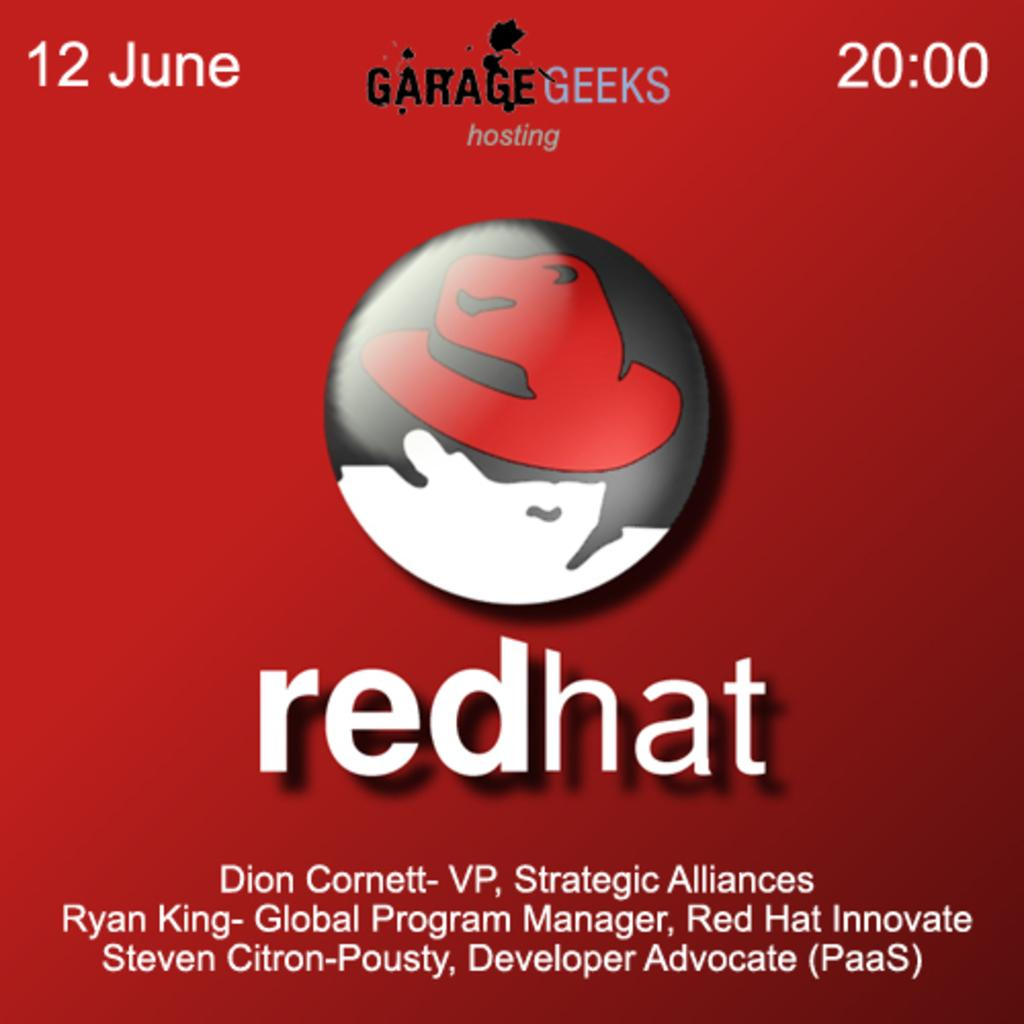What is the main object in the image? There is a poster in the image. What is featured in the center of the poster? The poster has a logo in the center. Where is text located on the poster? There is text at the top and bottom of the image. Can you describe the queen toad sitting on the horses in the image? There is no queen toad or horses present in the image. 